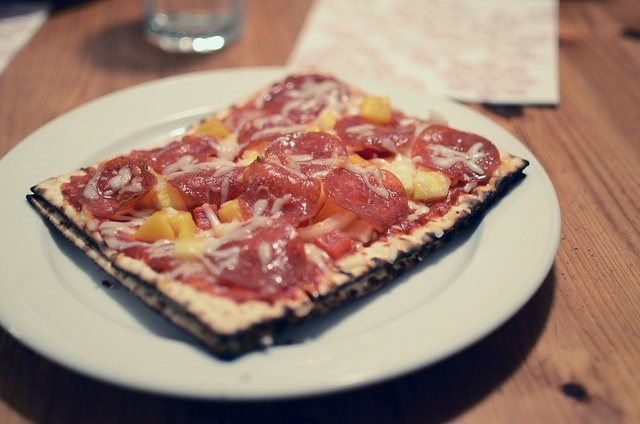Describe the objects in this image and their specific colors. I can see pizza in black, brown, and tan tones, dining table in black, gray, tan, and brown tones, and cup in black, gray, and darkgray tones in this image. 